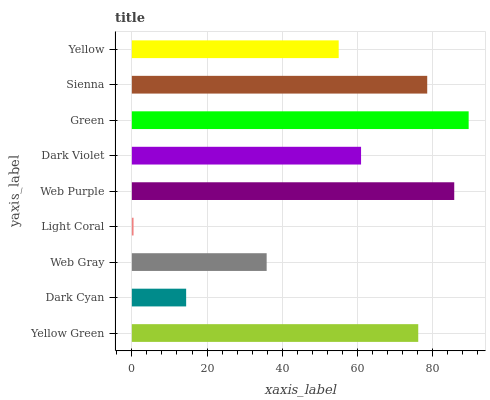Is Light Coral the minimum?
Answer yes or no. Yes. Is Green the maximum?
Answer yes or no. Yes. Is Dark Cyan the minimum?
Answer yes or no. No. Is Dark Cyan the maximum?
Answer yes or no. No. Is Yellow Green greater than Dark Cyan?
Answer yes or no. Yes. Is Dark Cyan less than Yellow Green?
Answer yes or no. Yes. Is Dark Cyan greater than Yellow Green?
Answer yes or no. No. Is Yellow Green less than Dark Cyan?
Answer yes or no. No. Is Dark Violet the high median?
Answer yes or no. Yes. Is Dark Violet the low median?
Answer yes or no. Yes. Is Green the high median?
Answer yes or no. No. Is Green the low median?
Answer yes or no. No. 